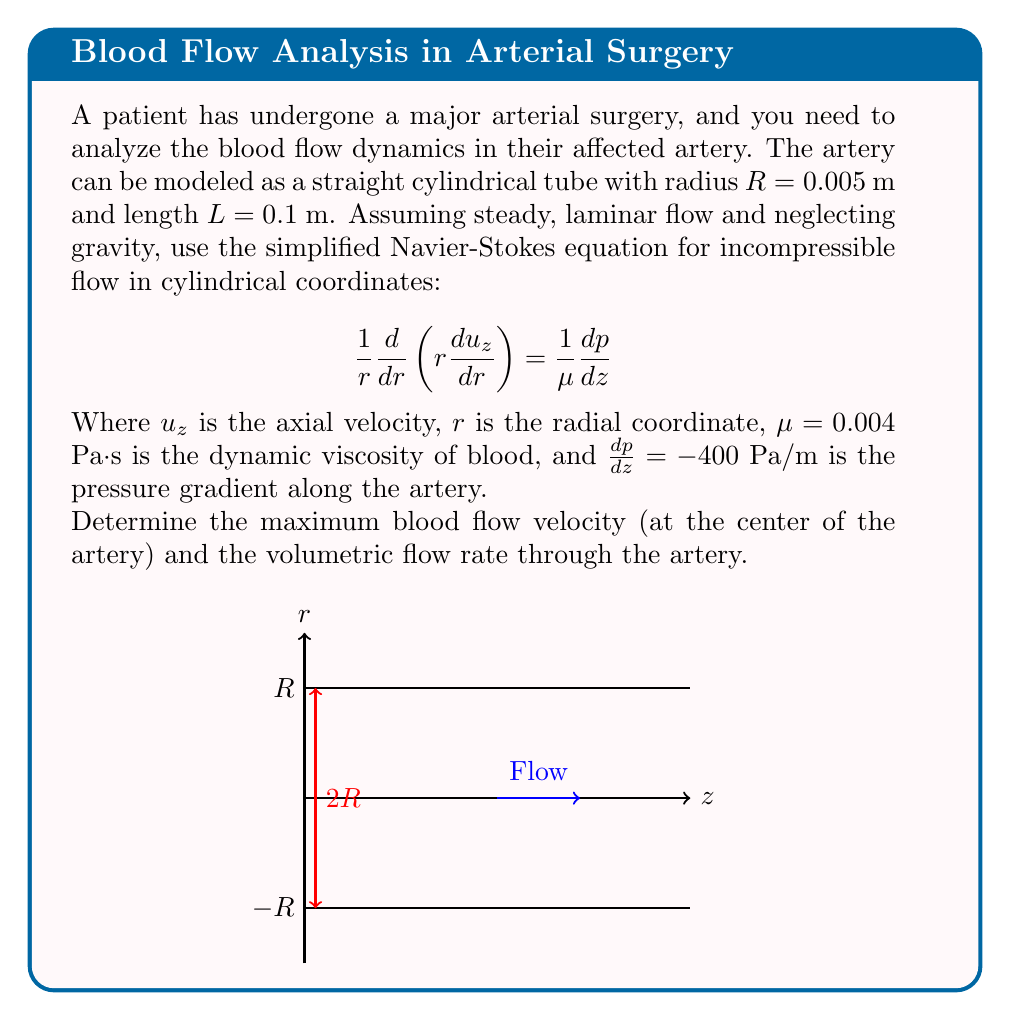Give your solution to this math problem. Let's solve this problem step by step:

1) The simplified Navier-Stokes equation for this scenario is:

   $$\frac{1}{r}\frac{d}{dr}\left(r\frac{du_z}{dr}\right) = \frac{1}{\mu}\frac{dp}{dz}$$

2) We can integrate this equation twice to find $u_z(r)$. First integration:

   $$r\frac{du_z}{dr} = \frac{r}{2\mu}\frac{dp}{dz} + C_1$$

3) Second integration:

   $$u_z(r) = \frac{1}{4\mu}\frac{dp}{dz}r^2 + C_1\ln(r) + C_2$$

4) Apply boundary conditions:
   - At $r = R$, $u_z = 0$ (no-slip condition at the wall)
   - At $r = 0$, $\frac{du_z}{dr} = 0$ (symmetry at the center)

5) From the second condition, we find that $C_1 = 0$ (to avoid singularity at $r = 0$).

6) From the first condition:

   $$0 = \frac{1}{4\mu}\frac{dp}{dz}R^2 + C_2$$
   $$C_2 = -\frac{1}{4\mu}\frac{dp}{dz}R^2$$

7) Therefore, the velocity profile is:

   $$u_z(r) = \frac{1}{4\mu}\frac{dp}{dz}(r^2 - R^2)$$

8) The maximum velocity occurs at the center ($r = 0$):

   $$u_{max} = -\frac{R^2}{4\mu}\frac{dp}{dz}$$

9) Substituting the given values:

   $$u_{max} = -\frac{(0.005)^2}{4(0.004)}(-400) = 0.3125 \text{ m/s}$$

10) To find the volumetric flow rate, we integrate the velocity profile over the cross-sectional area:

    $$Q = \int_0^R 2\pi r u_z(r) dr = \frac{\pi R^4}{8\mu}\left(-\frac{dp}{dz}\right)$$

11) Substituting the values:

    $$Q = \frac{\pi (0.005)^4}{8(0.004)}(400) = 1.227 \times 10^{-5} \text{ m}^3/\text{s} = 12.27 \text{ mL/s}$$
Answer: Maximum velocity: $0.3125 \text{ m/s}$, Volumetric flow rate: $12.27 \text{ mL/s}$ 